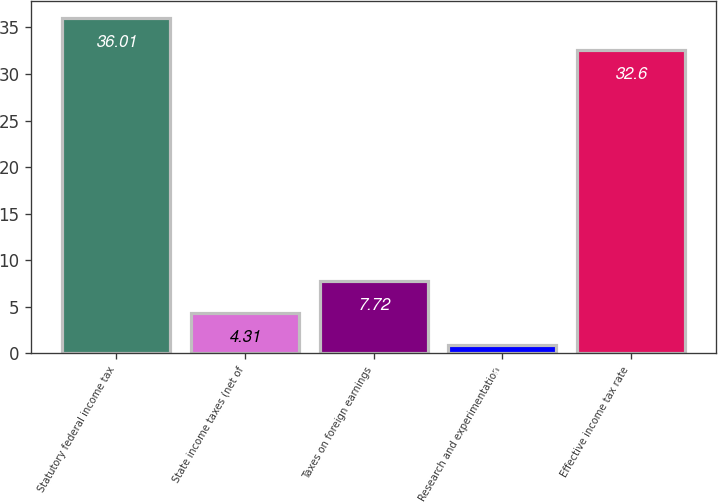Convert chart to OTSL. <chart><loc_0><loc_0><loc_500><loc_500><bar_chart><fcel>Statutory federal income tax<fcel>State income taxes (net of<fcel>Taxes on foreign earnings<fcel>Research and experimentation<fcel>Effective income tax rate<nl><fcel>36.01<fcel>4.31<fcel>7.72<fcel>0.9<fcel>32.6<nl></chart> 